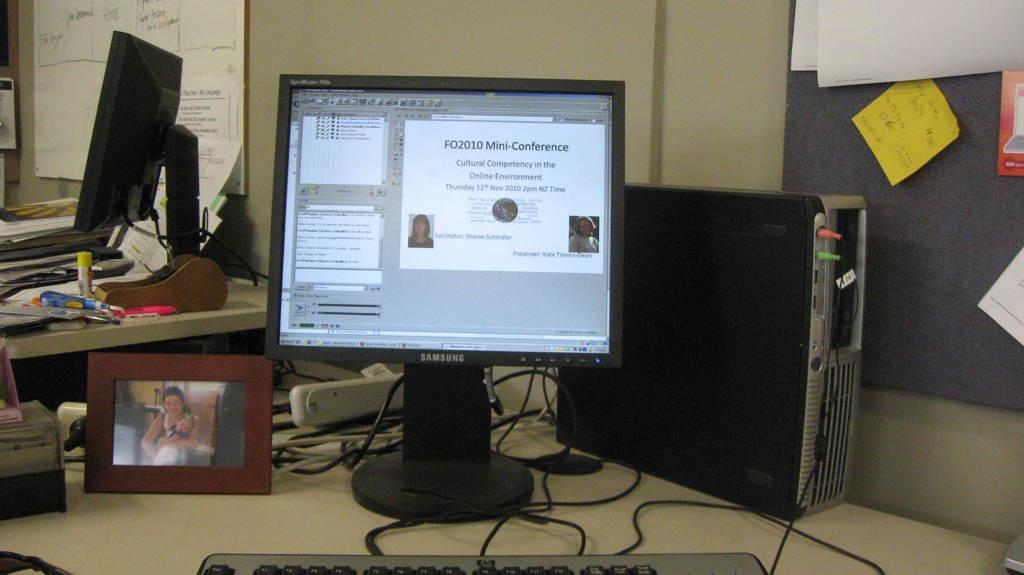<image>
Create a compact narrative representing the image presented. a samsung computer monitor with a power point slide up 